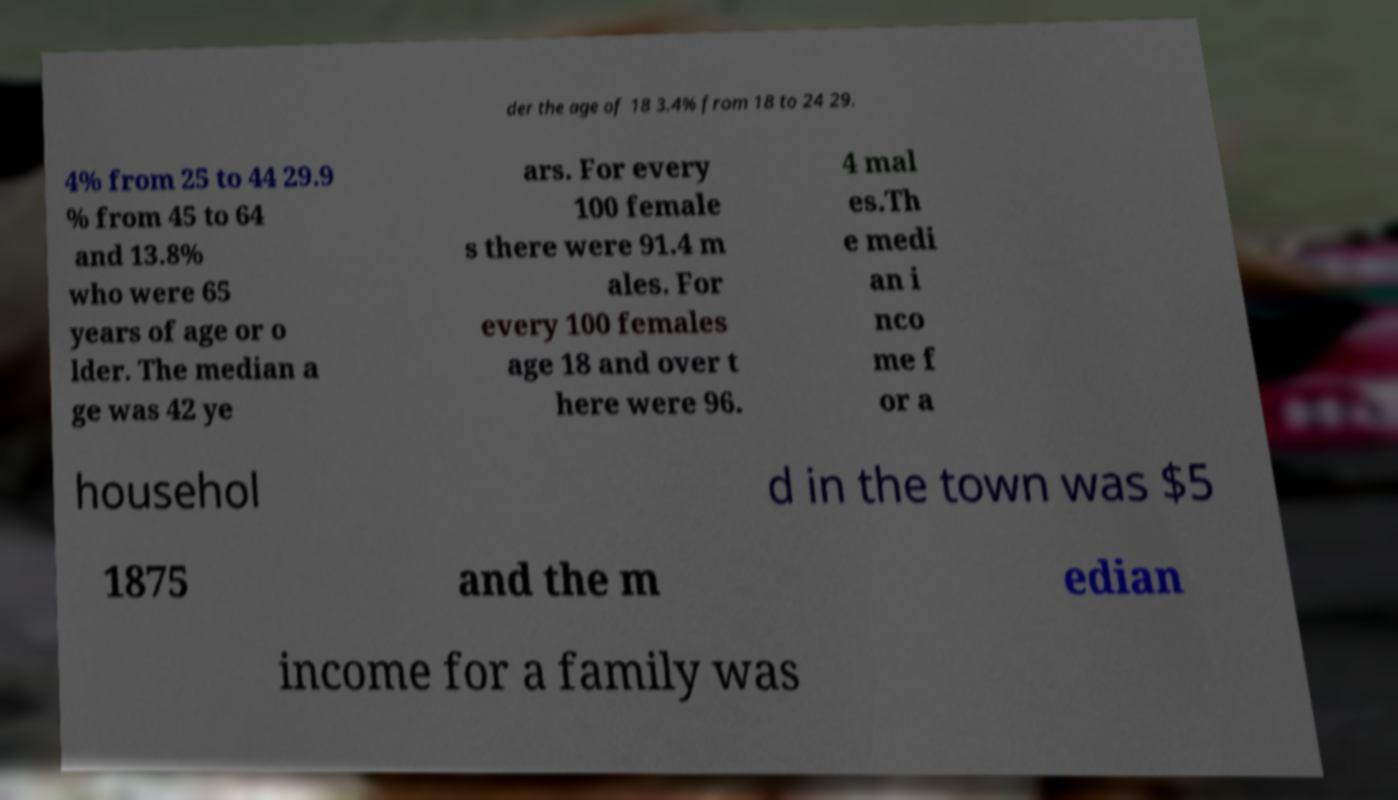Could you assist in decoding the text presented in this image and type it out clearly? der the age of 18 3.4% from 18 to 24 29. 4% from 25 to 44 29.9 % from 45 to 64 and 13.8% who were 65 years of age or o lder. The median a ge was 42 ye ars. For every 100 female s there were 91.4 m ales. For every 100 females age 18 and over t here were 96. 4 mal es.Th e medi an i nco me f or a househol d in the town was $5 1875 and the m edian income for a family was 